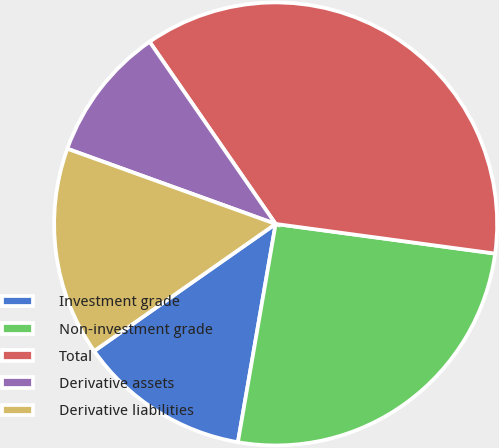<chart> <loc_0><loc_0><loc_500><loc_500><pie_chart><fcel>Investment grade<fcel>Non-investment grade<fcel>Total<fcel>Derivative assets<fcel>Derivative liabilities<nl><fcel>12.55%<fcel>25.59%<fcel>36.77%<fcel>9.85%<fcel>15.24%<nl></chart> 